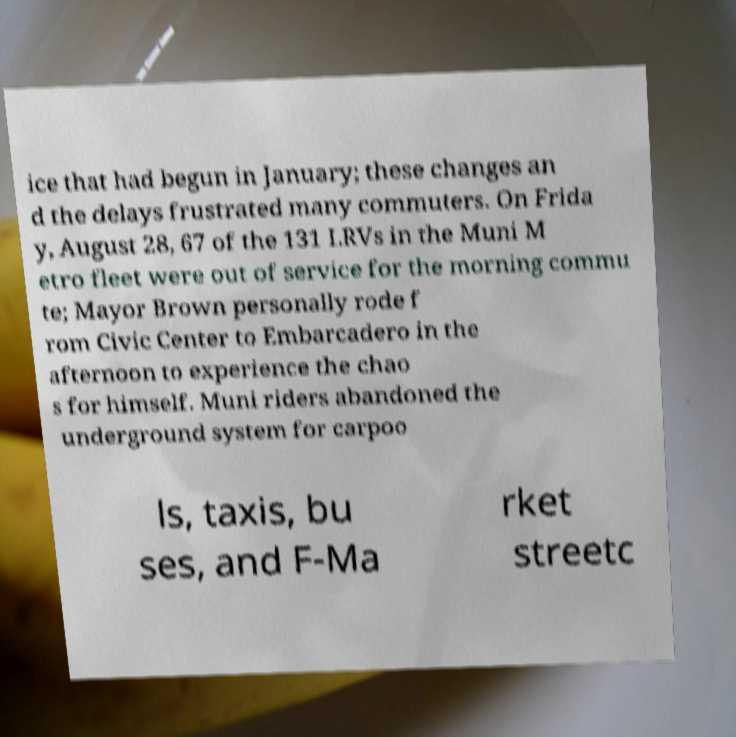Can you accurately transcribe the text from the provided image for me? ice that had begun in January; these changes an d the delays frustrated many commuters. On Frida y, August 28, 67 of the 131 LRVs in the Muni M etro fleet were out of service for the morning commu te; Mayor Brown personally rode f rom Civic Center to Embarcadero in the afternoon to experience the chao s for himself. Muni riders abandoned the underground system for carpoo ls, taxis, bu ses, and F-Ma rket streetc 